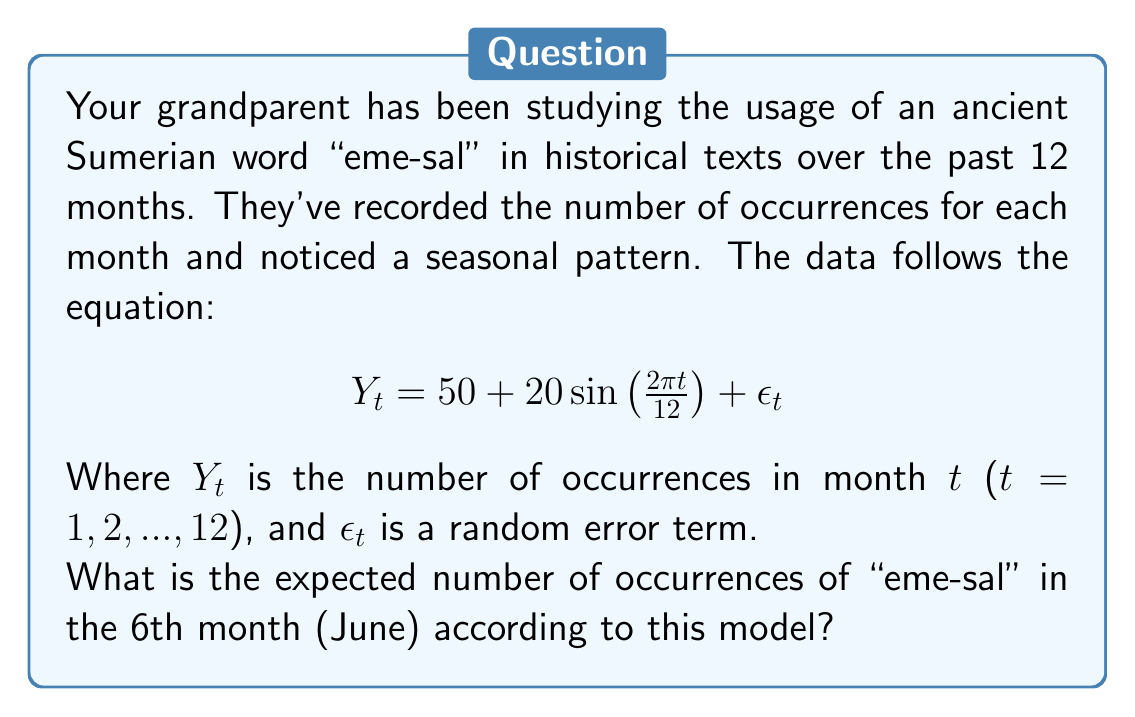What is the answer to this math problem? To solve this problem, we need to understand the components of the given time series equation:

1. $50$ is the baseline or average number of occurrences.
2. $20\sin\left(\frac{2\pi t}{12}\right)$ is the seasonal component.
3. $\epsilon_t$ is the random error term, which we ignore for expected values.

The seasonal component has a period of 12 months, corresponding to annual seasonality. To find the expected number of occurrences in June (the 6th month), we need to calculate:

$$Y_6 = 50 + 20\sin\left(\frac{2\pi \cdot 6}{12}\right)$$

Let's break it down step-by-step:

1. Calculate the argument of the sine function:
   $$\frac{2\pi \cdot 6}{12} = \pi$$

2. Evaluate $\sin(\pi)$:
   $$\sin(\pi) = 0$$

3. Multiply by 20:
   $$20 \cdot 0 = 0$$

4. Add the result to the baseline:
   $$50 + 0 = 50$$

Therefore, the expected number of occurrences of "eme-sal" in June is 50.
Answer: 50 occurrences 